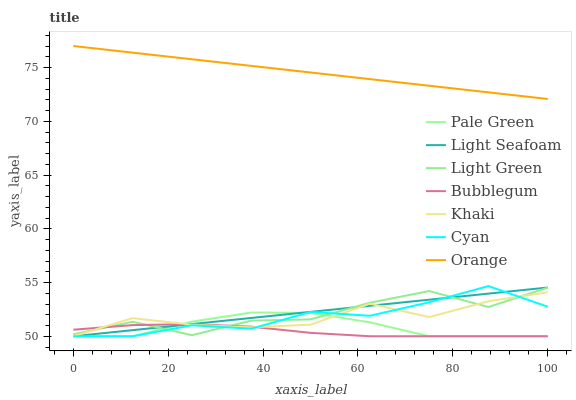Does Bubblegum have the minimum area under the curve?
Answer yes or no. Yes. Does Orange have the maximum area under the curve?
Answer yes or no. Yes. Does Pale Green have the minimum area under the curve?
Answer yes or no. No. Does Pale Green have the maximum area under the curve?
Answer yes or no. No. Is Light Seafoam the smoothest?
Answer yes or no. Yes. Is Light Green the roughest?
Answer yes or no. Yes. Is Bubblegum the smoothest?
Answer yes or no. No. Is Bubblegum the roughest?
Answer yes or no. No. Does Khaki have the lowest value?
Answer yes or no. Yes. Does Light Green have the lowest value?
Answer yes or no. No. Does Orange have the highest value?
Answer yes or no. Yes. Does Pale Green have the highest value?
Answer yes or no. No. Is Light Seafoam less than Orange?
Answer yes or no. Yes. Is Orange greater than Pale Green?
Answer yes or no. Yes. Does Cyan intersect Pale Green?
Answer yes or no. Yes. Is Cyan less than Pale Green?
Answer yes or no. No. Is Cyan greater than Pale Green?
Answer yes or no. No. Does Light Seafoam intersect Orange?
Answer yes or no. No. 